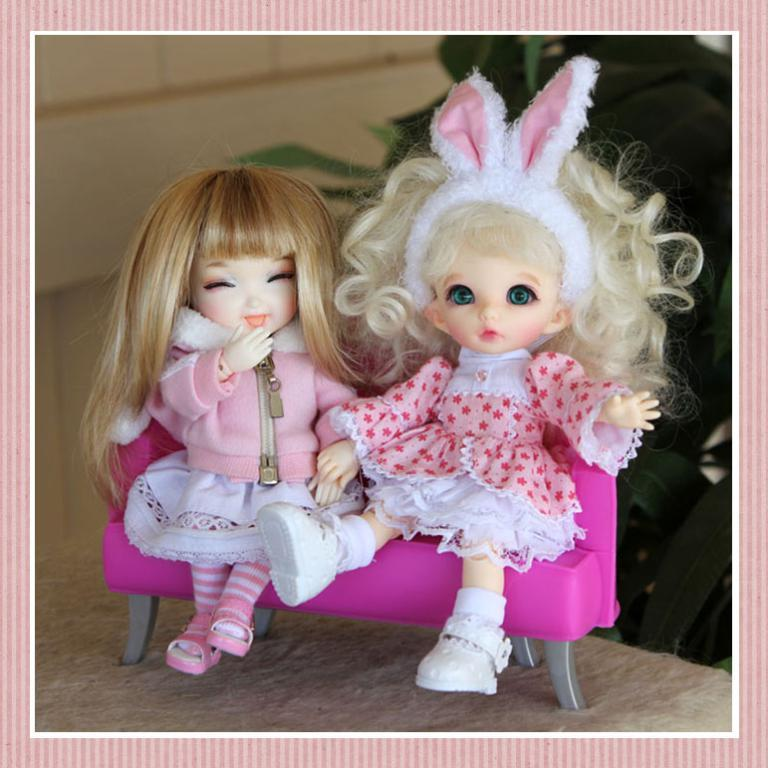What is the main subject of the image? There is a photograph on a platform in the image. What can be seen in the photograph? The photograph contains two dolls. What are the dolls doing in the photograph? The dolls are sitting on a sofa in the photograph. What is visible in the background of the photograph? The photograph has a background with a wall and plants. What type of dinner is being served on the table in the image? There is no table or dinner present in the image; it features a photograph of two dolls sitting on a sofa. Can you tell me how many sponges are visible in the image? There are no sponges visible in the image; it features a photograph of two dolls sitting on a sofa. 